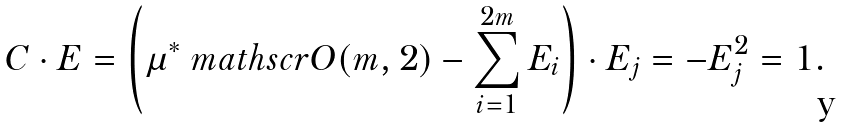Convert formula to latex. <formula><loc_0><loc_0><loc_500><loc_500>C \cdot E = \left ( \mu ^ { * } \ m a t h s c r O ( m , 2 ) - \sum _ { i = 1 } ^ { 2 m } E _ { i } \right ) \cdot E _ { j } = - E _ { j } ^ { 2 } = 1 .</formula> 